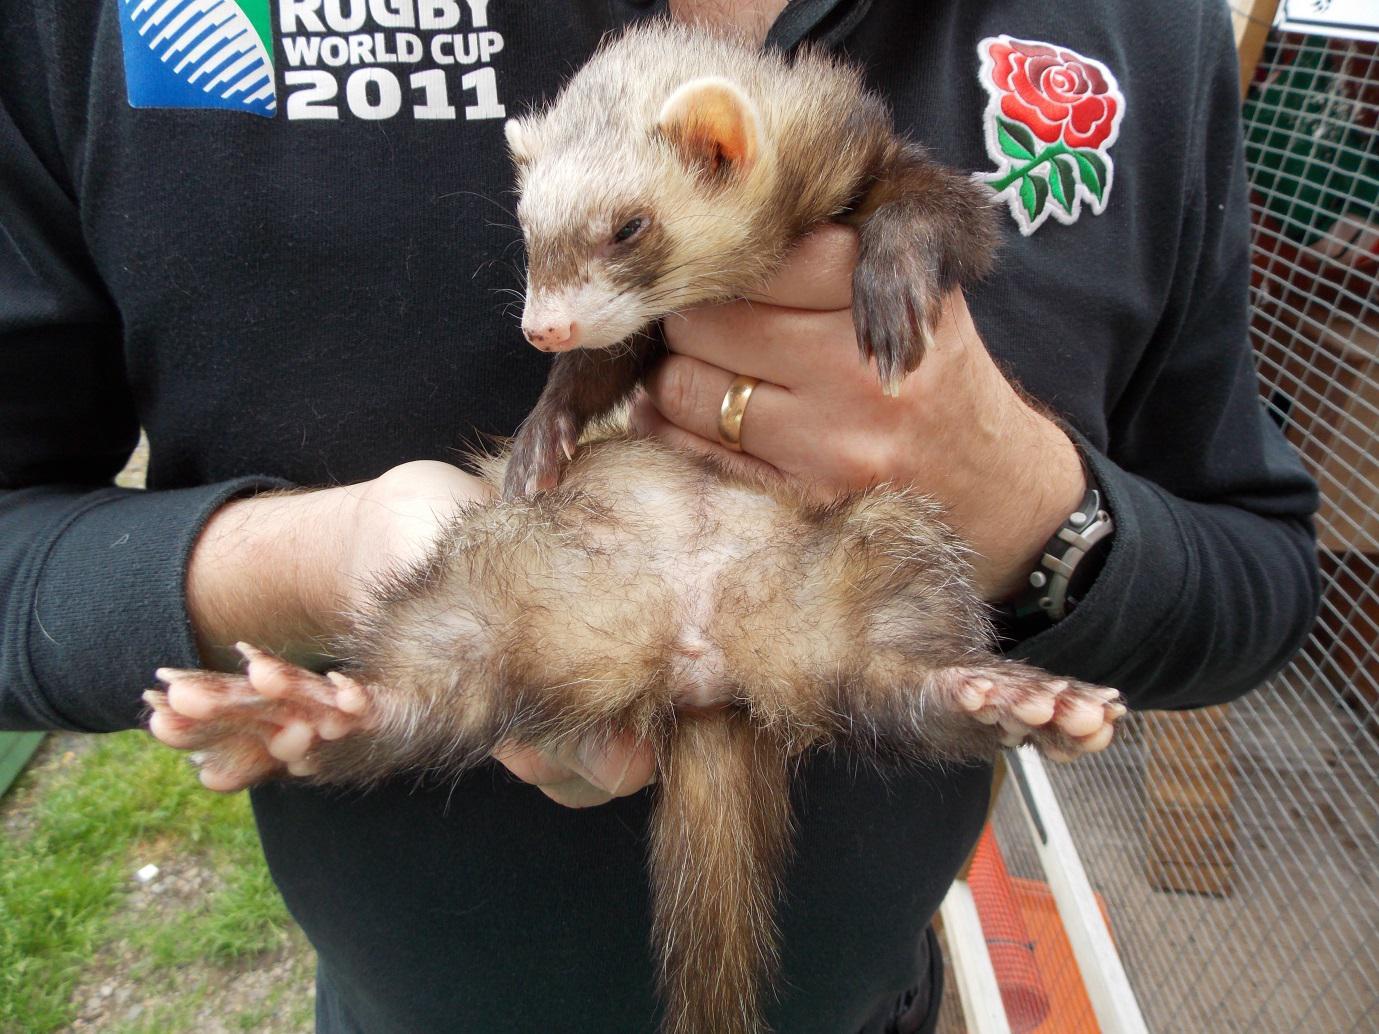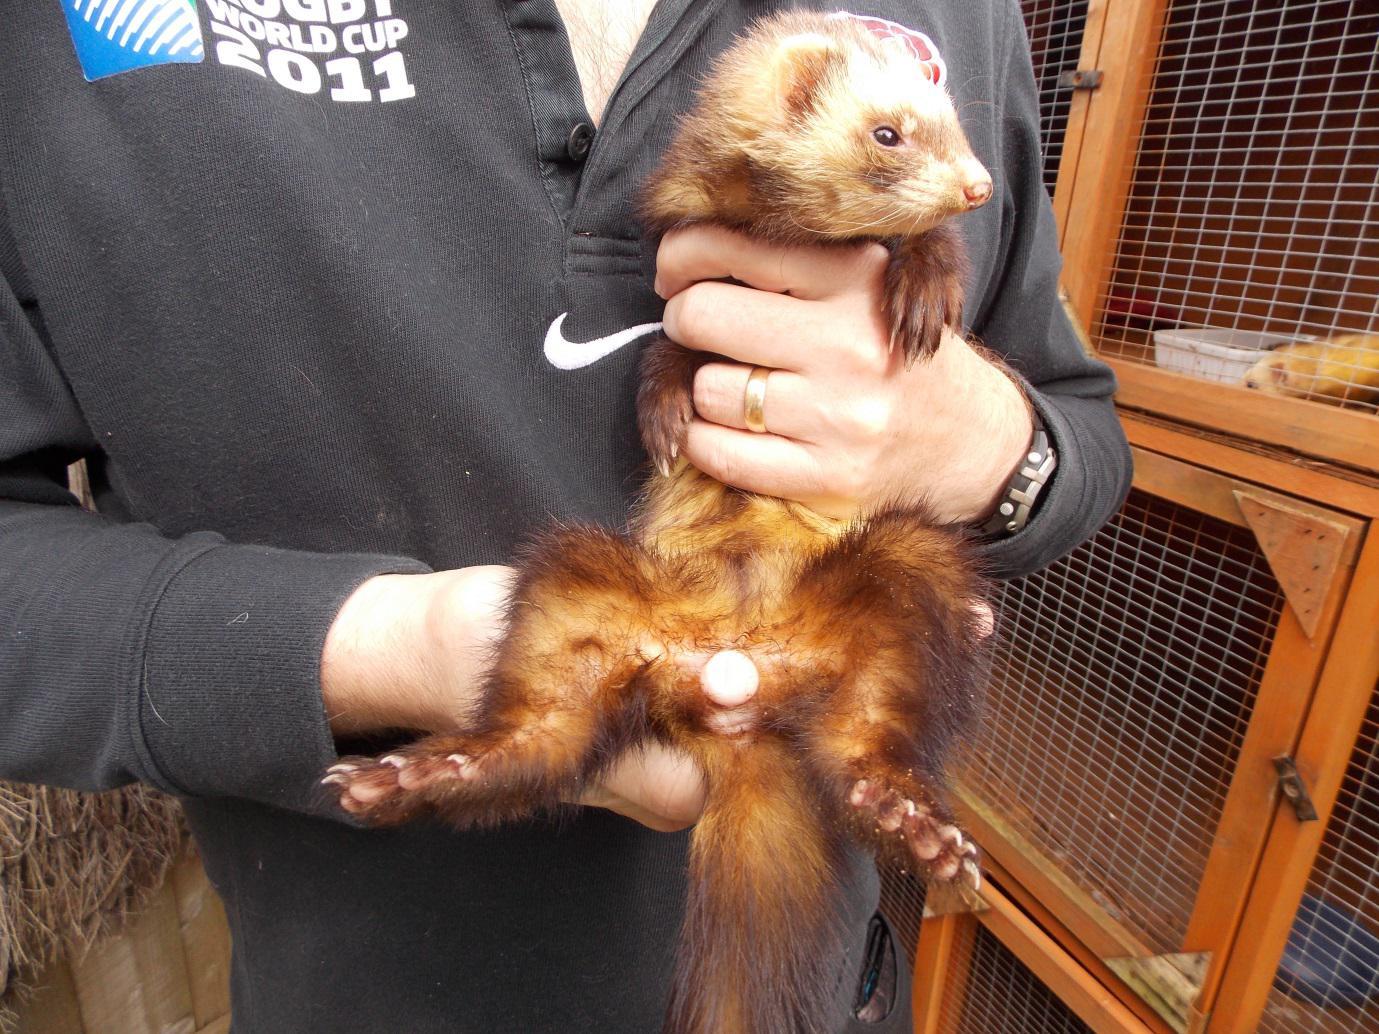The first image is the image on the left, the second image is the image on the right. Evaluate the accuracy of this statement regarding the images: "Someone is holding all the animals in the images.". Is it true? Answer yes or no. Yes. 